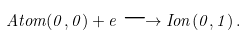<formula> <loc_0><loc_0><loc_500><loc_500>A t o m ( 0 , 0 ) + e \longrightarrow I o n ( 0 , 1 ) \, .</formula> 